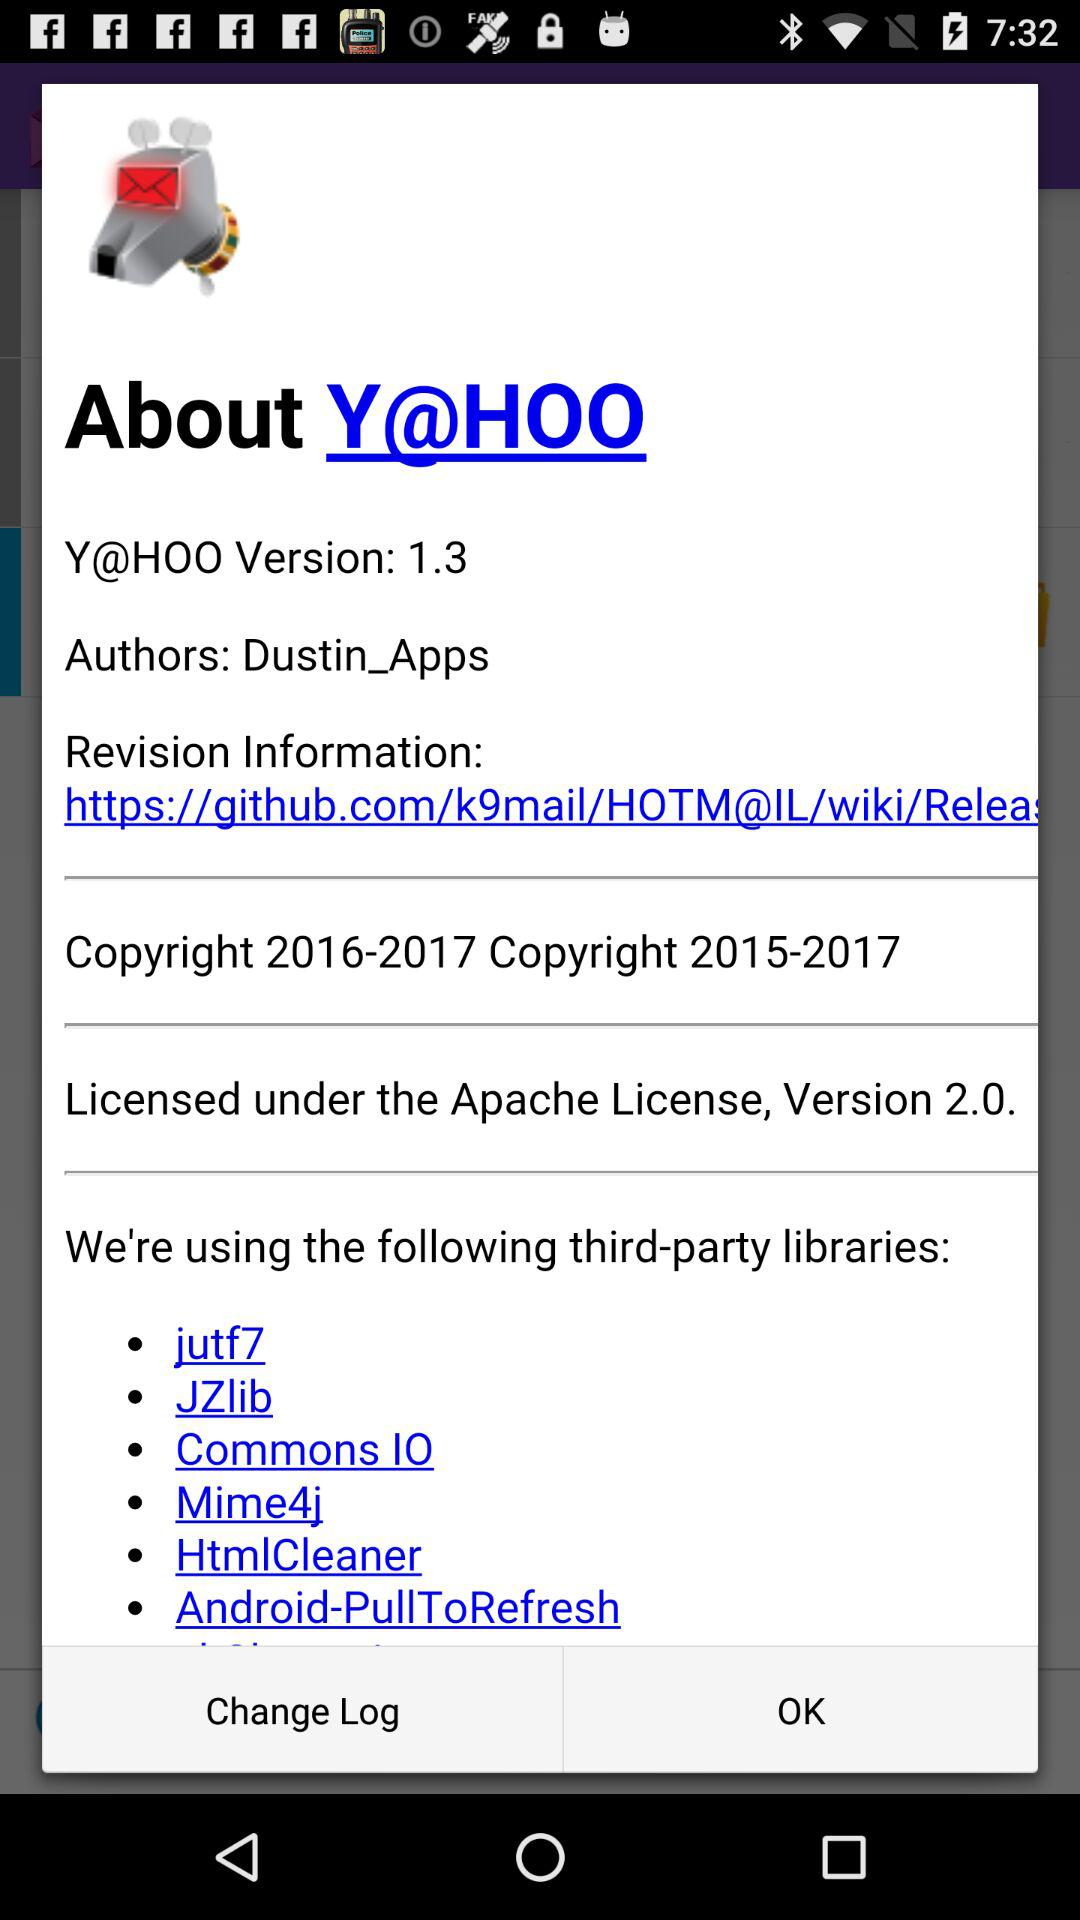What is the version of "Y@HOO"? The version is 1.3. 